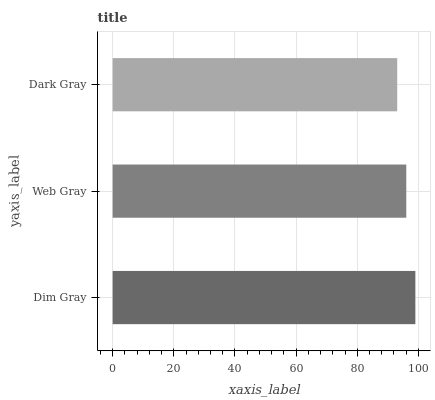Is Dark Gray the minimum?
Answer yes or no. Yes. Is Dim Gray the maximum?
Answer yes or no. Yes. Is Web Gray the minimum?
Answer yes or no. No. Is Web Gray the maximum?
Answer yes or no. No. Is Dim Gray greater than Web Gray?
Answer yes or no. Yes. Is Web Gray less than Dim Gray?
Answer yes or no. Yes. Is Web Gray greater than Dim Gray?
Answer yes or no. No. Is Dim Gray less than Web Gray?
Answer yes or no. No. Is Web Gray the high median?
Answer yes or no. Yes. Is Web Gray the low median?
Answer yes or no. Yes. Is Dark Gray the high median?
Answer yes or no. No. Is Dark Gray the low median?
Answer yes or no. No. 